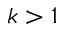<formula> <loc_0><loc_0><loc_500><loc_500>k > 1</formula> 